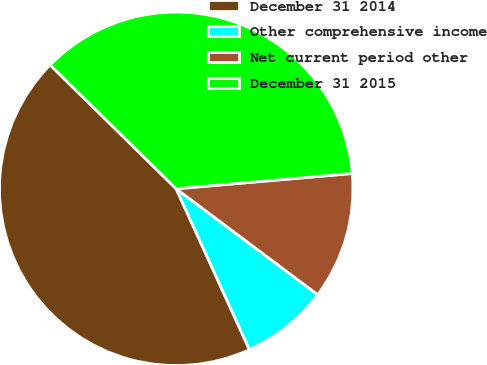<chart> <loc_0><loc_0><loc_500><loc_500><pie_chart><fcel>December 31 2014<fcel>Other comprehensive income<fcel>Net current period other<fcel>December 31 2015<nl><fcel>44.16%<fcel>7.98%<fcel>11.6%<fcel>36.26%<nl></chart> 